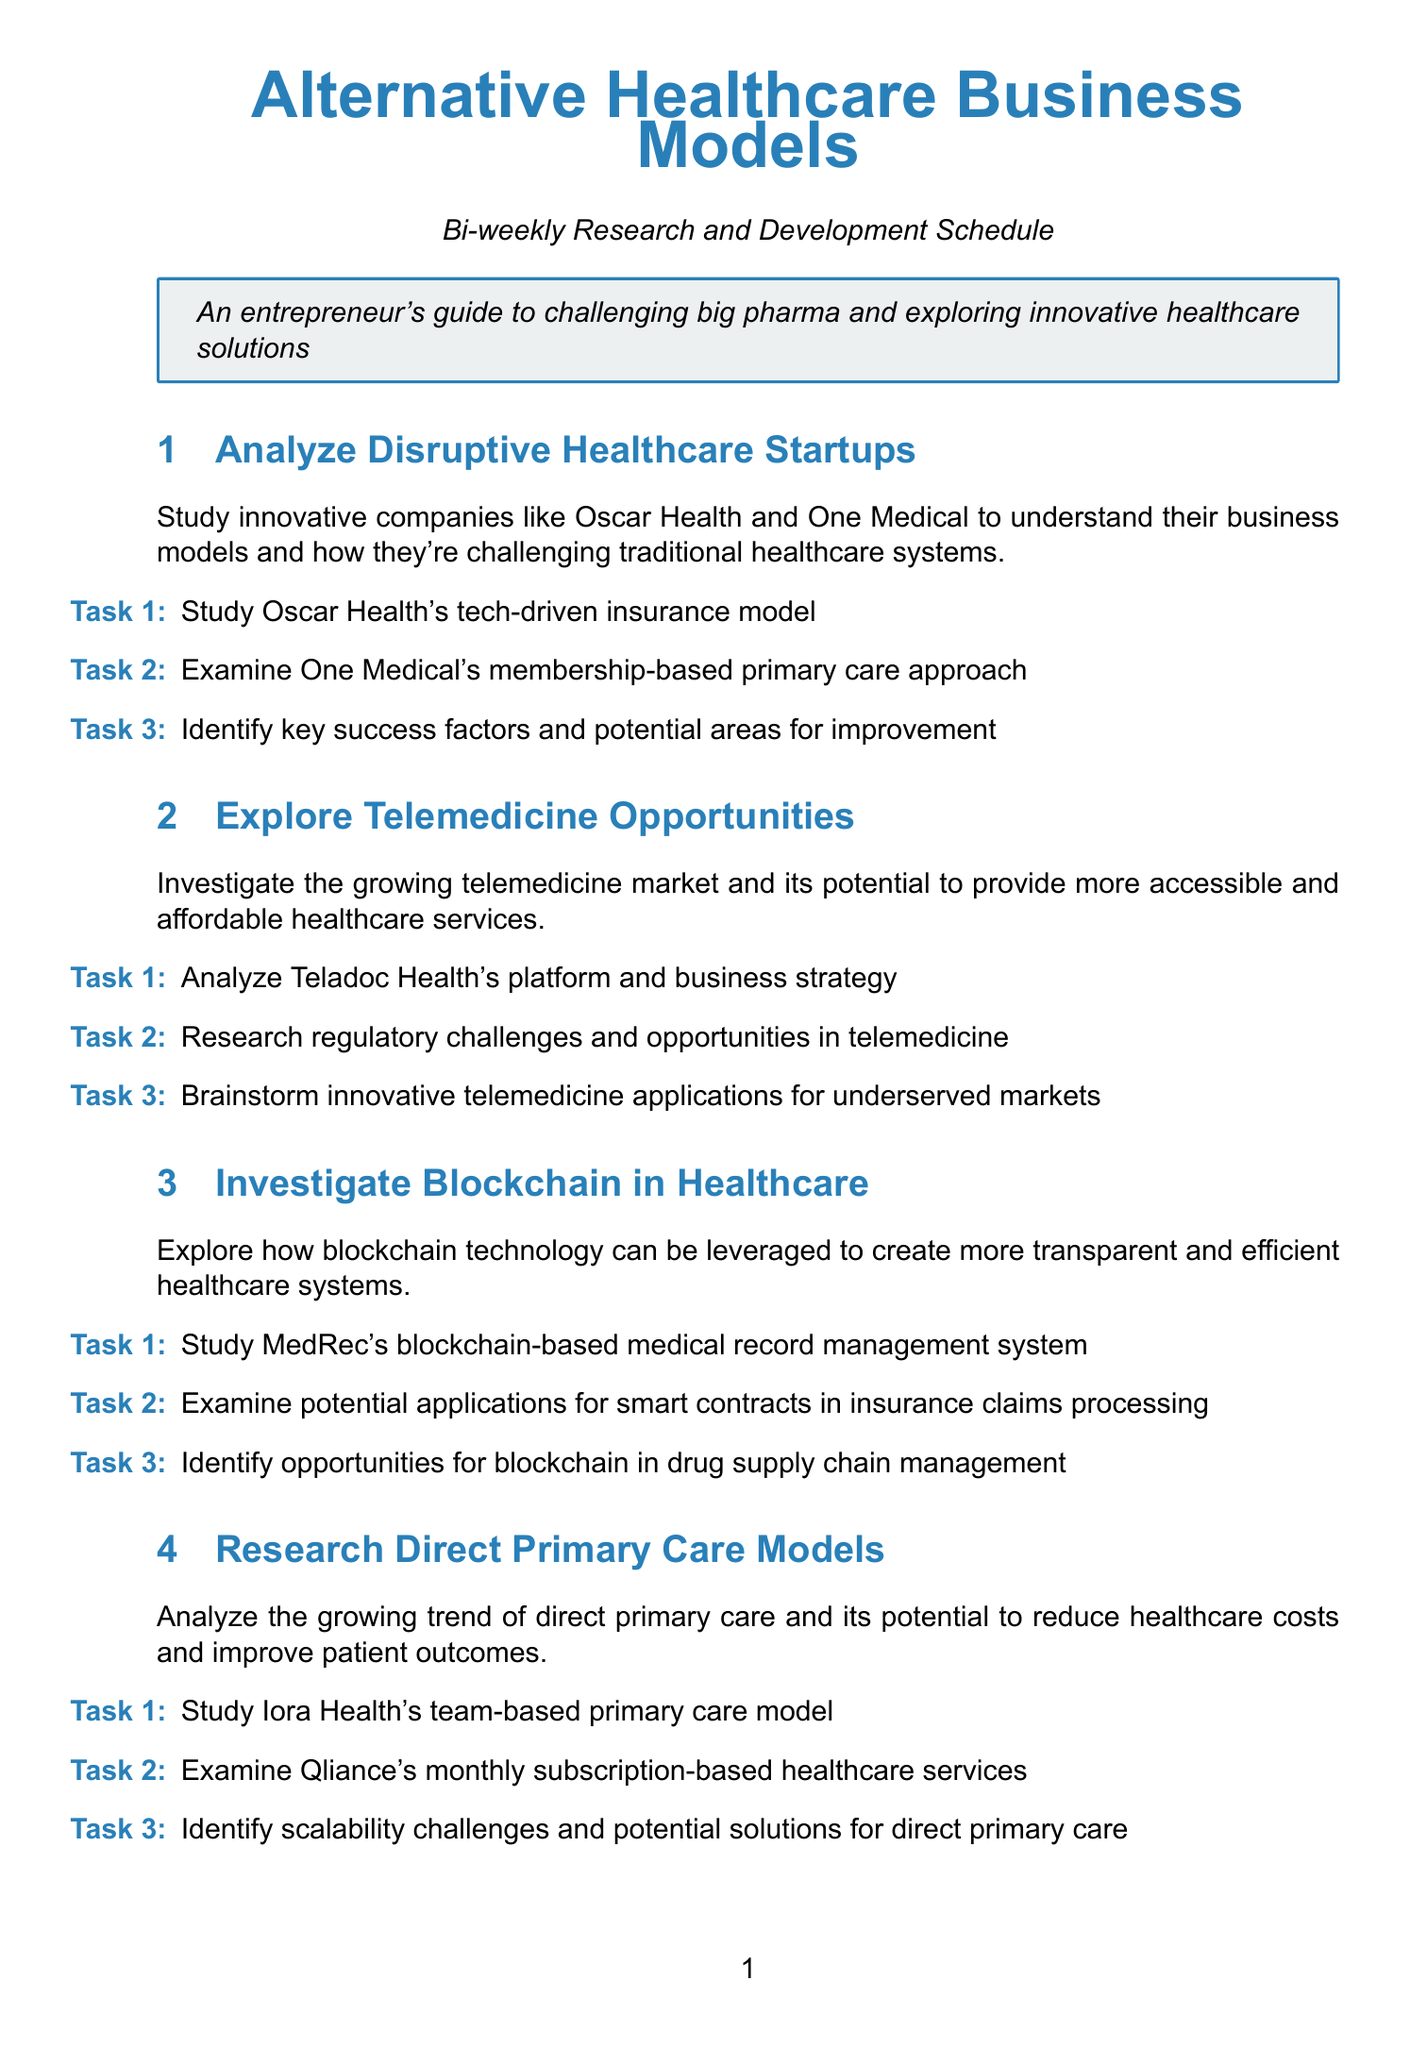What is the title of the first research topic? The title of the first research topic is given at the beginning of each section, which is "Analyze Disruptive Healthcare Startups."
Answer: Analyze Disruptive Healthcare Startups How many tasks are listed under the "Explore Telemedicine Opportunities" section? Each section includes three specific tasks, including the one under "Explore Telemedicine Opportunities."
Answer: 3 Which company's business model is studied in the "Investigate Blockchain in Healthcare" section? The document lists MedRec's blockchain-based medical record management system under this section, indicating the company being studied.
Answer: MedRec What is the main focus of the "Research Direct Primary Care Models" section? The main focus is described in the section prompt, which indicates it analyzes the growing trend of direct primary care.
Answer: Direct primary care Which innovative technology is explored in the "Explore AI and Machine Learning in Healthcare" section? The section discusses how AI and machine learning can enhance patient care, indicating the focus on these technologies.
Answer: AI and machine learning What type of care models does the "Investigate Value-Based Care Models" section focus on? This section emphasizes alternative payment models that center on patient outcomes rather than service volume.
Answer: Value-based care models What does the "Explore Digital Therapeutics" section focus on? The focus is on the growing field of digital therapeutics and evidence-based interventions through software applications.
Answer: Digital therapeutics Which company is highlighted in the "Study Healthcare Consumerism" section? One of the companies mentioned is GoodRx, which is relevant to healthcare consumerism.
Answer: GoodRx What is the theme of the final research topic, "Investigate Precision Medicine Models"? The theme is focused on leveraging genetic testing and personalized medicine.
Answer: Genetic testing and personalized medicine 